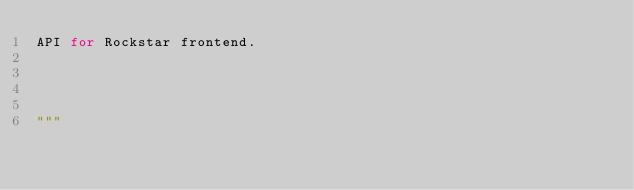Convert code to text. <code><loc_0><loc_0><loc_500><loc_500><_Python_>API for Rockstar frontend.




"""

</code> 